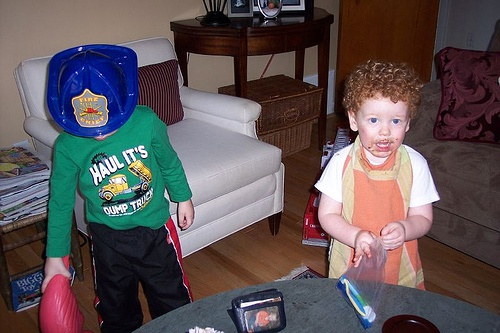Describe the objects in this image and their specific colors. I can see people in gray, black, teal, and navy tones, people in gray, lavender, lightpink, brown, and tan tones, chair in gray, darkgray, black, and lightgray tones, dining table in gray, black, and darkblue tones, and couch in gray and black tones in this image. 